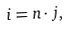Convert formula to latex. <formula><loc_0><loc_0><loc_500><loc_500>i & = n \cdot j ,</formula> 